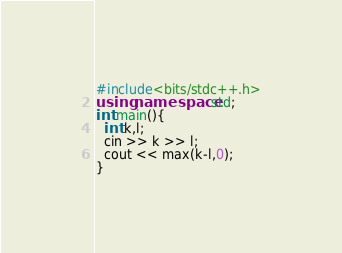Convert code to text. <code><loc_0><loc_0><loc_500><loc_500><_C++_>#include<bits/stdc++.h>
using namespace std;
int main(){
  int k,l;
  cin >> k >> l;
  cout << max(k-l,0);
}</code> 